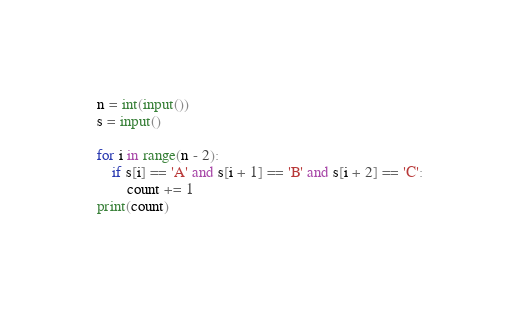Convert code to text. <code><loc_0><loc_0><loc_500><loc_500><_Python_>n = int(input())
s = input()

for i in range(n - 2):
    if s[i] == 'A' and s[i + 1] == 'B' and s[i + 2] == 'C':
        count += 1
print(count)
</code> 